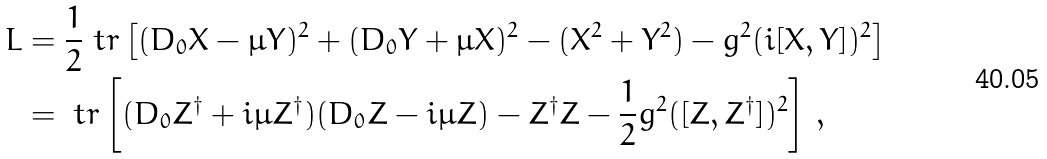Convert formula to latex. <formula><loc_0><loc_0><loc_500><loc_500>L & = \frac { 1 } { 2 } \ t r \left [ ( D _ { 0 } X - \mu Y ) ^ { 2 } + ( D _ { 0 } Y + \mu X ) ^ { 2 } - ( X ^ { 2 } + Y ^ { 2 } ) - g ^ { 2 } ( i [ X , Y ] ) ^ { 2 } \right ] \\ & = \ t r \left [ ( D _ { 0 } Z ^ { \dagger } + i \mu Z ^ { \dagger } ) ( D _ { 0 } Z - i \mu Z ) - Z ^ { \dagger } Z - \frac { 1 } { 2 } g ^ { 2 } ( [ Z , Z ^ { \dagger } ] ) ^ { 2 } \right ] \, ,</formula> 